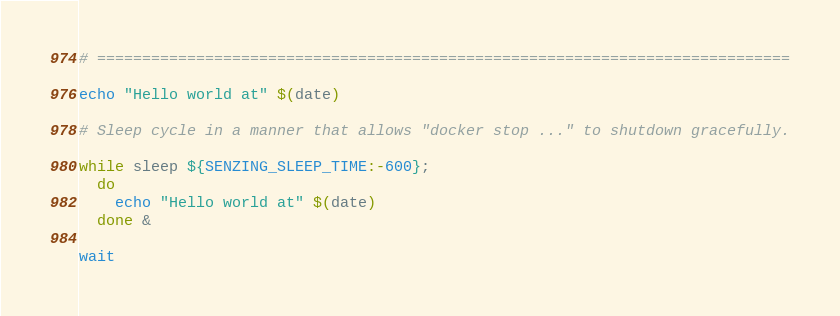<code> <loc_0><loc_0><loc_500><loc_500><_Bash_># =============================================================================

echo "Hello world at" $(date)

# Sleep cycle in a manner that allows "docker stop ..." to shutdown gracefully.

while sleep ${SENZING_SLEEP_TIME:-600};
  do
    echo "Hello world at" $(date)
  done &

wait
</code> 